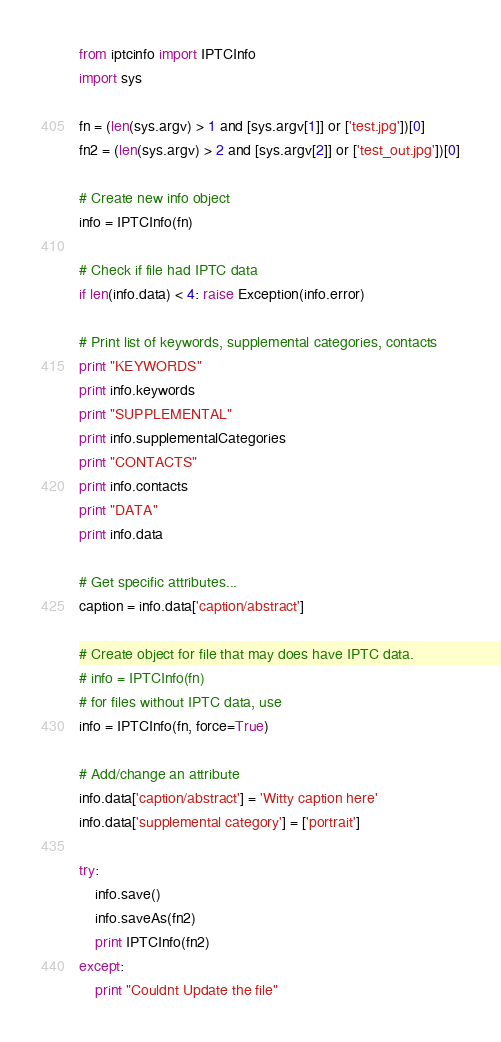Convert code to text. <code><loc_0><loc_0><loc_500><loc_500><_Python_>from iptcinfo import IPTCInfo
import sys

fn = (len(sys.argv) > 1 and [sys.argv[1]] or ['test.jpg'])[0]
fn2 = (len(sys.argv) > 2 and [sys.argv[2]] or ['test_out.jpg'])[0]

# Create new info object
info = IPTCInfo(fn)

# Check if file had IPTC data
if len(info.data) < 4: raise Exception(info.error)

# Print list of keywords, supplemental categories, contacts
print "KEYWORDS"
print info.keywords
print "SUPPLEMENTAL"
print info.supplementalCategories
print "CONTACTS"
print info.contacts
print "DATA"
print info.data

# Get specific attributes...
caption = info.data['caption/abstract']

# Create object for file that may does have IPTC data.
# info = IPTCInfo(fn)
# for files without IPTC data, use
info = IPTCInfo(fn, force=True)

# Add/change an attribute
info.data['caption/abstract'] = 'Witty caption here'
info.data['supplemental category'] = ['portrait']

try:
    info.save()
    info.saveAs(fn2)
    print IPTCInfo(fn2)
except:
    print "Couldnt Update the file"
</code> 